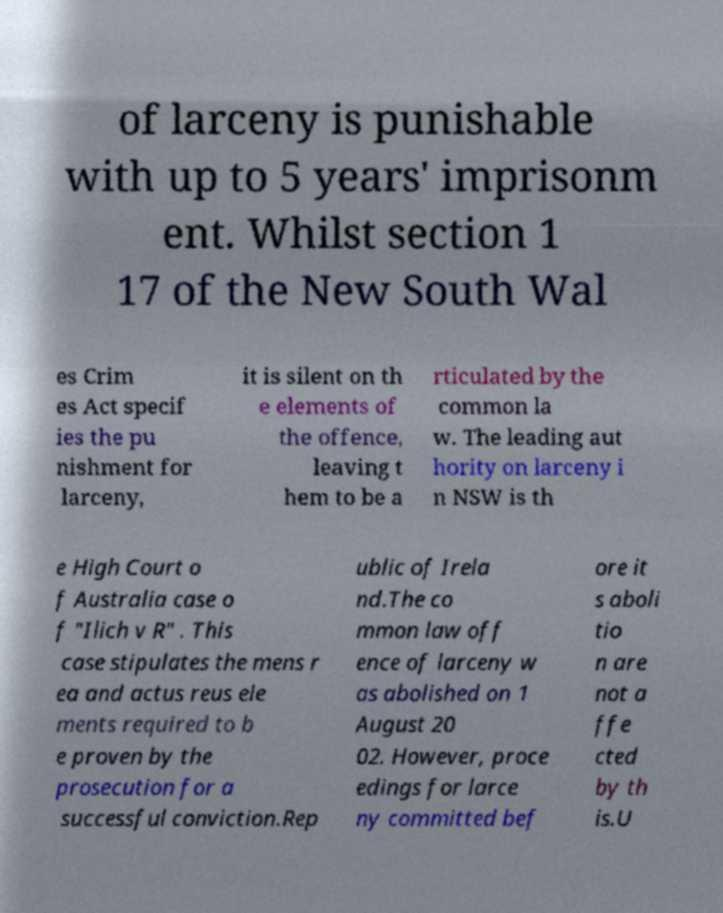Could you assist in decoding the text presented in this image and type it out clearly? of larceny is punishable with up to 5 years' imprisonm ent. Whilst section 1 17 of the New South Wal es Crim es Act specif ies the pu nishment for larceny, it is silent on th e elements of the offence, leaving t hem to be a rticulated by the common la w. The leading aut hority on larceny i n NSW is th e High Court o f Australia case o f "Ilich v R" . This case stipulates the mens r ea and actus reus ele ments required to b e proven by the prosecution for a successful conviction.Rep ublic of Irela nd.The co mmon law off ence of larceny w as abolished on 1 August 20 02. However, proce edings for larce ny committed bef ore it s aboli tio n are not a ffe cted by th is.U 